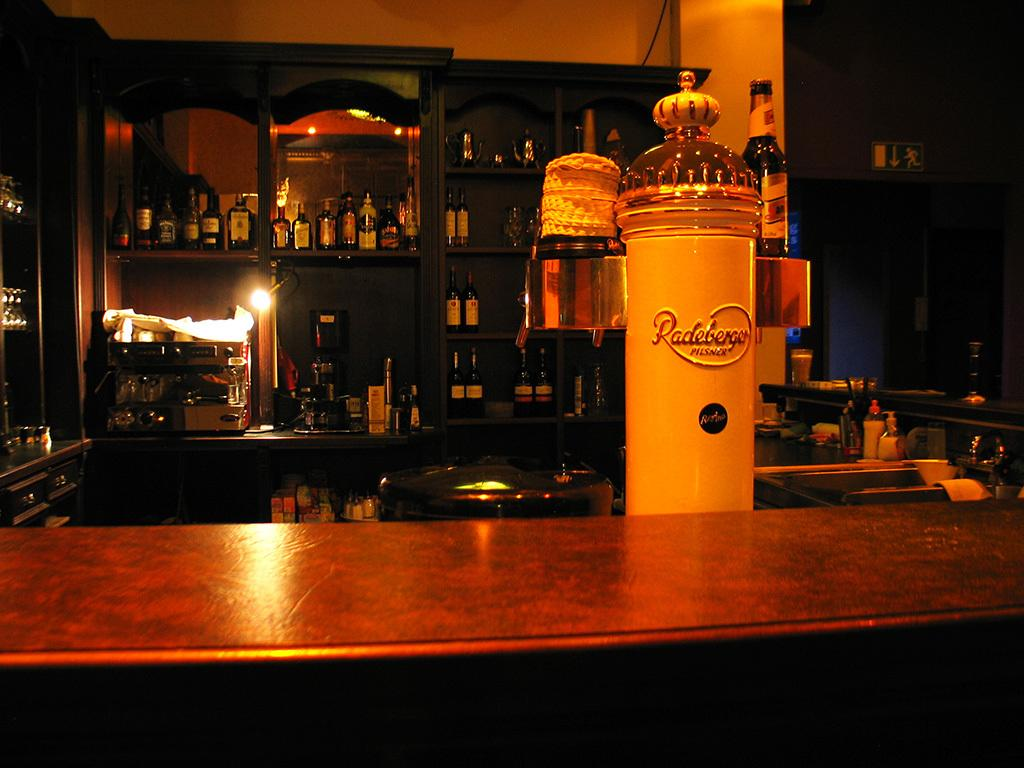What color is the bottle in the image? The bottle in the image is white. What is located in front of the bottle? There is a table in front of the bottle. What can be seen in the background of the image? There are bottles visible on shelves, a light, a wall, and a sign in the background. What else is present on the table besides the bottle? There are other materials on the table. What type of lunch is being served on the table in the image? There is no lunch visible in the image; it only shows a white bottle on a table with other materials. How many glasses are present on the table in the image? There is no mention of glasses in the image; it only shows a white bottle and other materials on the table. 